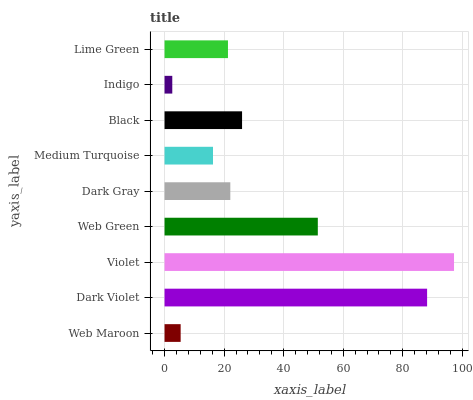Is Indigo the minimum?
Answer yes or no. Yes. Is Violet the maximum?
Answer yes or no. Yes. Is Dark Violet the minimum?
Answer yes or no. No. Is Dark Violet the maximum?
Answer yes or no. No. Is Dark Violet greater than Web Maroon?
Answer yes or no. Yes. Is Web Maroon less than Dark Violet?
Answer yes or no. Yes. Is Web Maroon greater than Dark Violet?
Answer yes or no. No. Is Dark Violet less than Web Maroon?
Answer yes or no. No. Is Dark Gray the high median?
Answer yes or no. Yes. Is Dark Gray the low median?
Answer yes or no. Yes. Is Web Maroon the high median?
Answer yes or no. No. Is Web Green the low median?
Answer yes or no. No. 